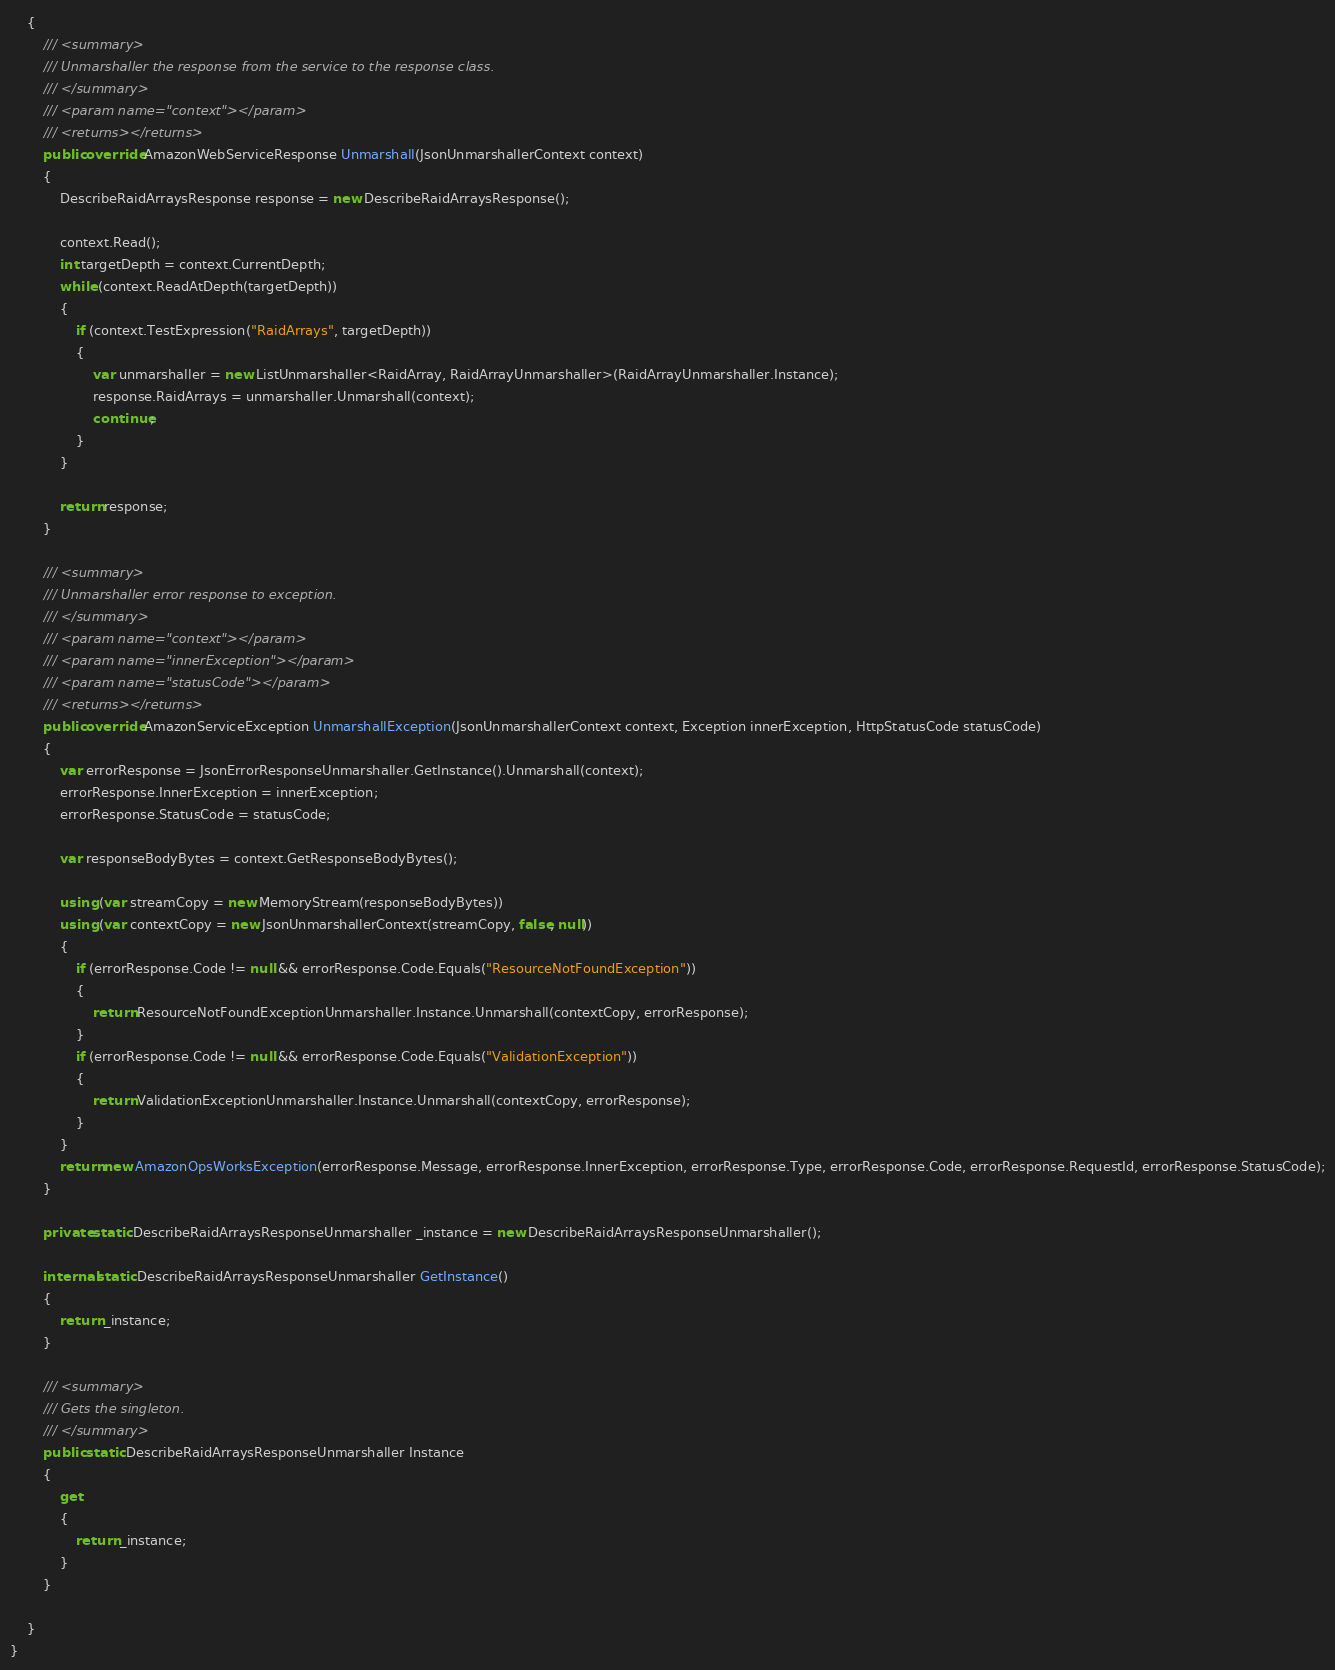Convert code to text. <code><loc_0><loc_0><loc_500><loc_500><_C#_>    {
        /// <summary>
        /// Unmarshaller the response from the service to the response class.
        /// </summary>  
        /// <param name="context"></param>
        /// <returns></returns>
        public override AmazonWebServiceResponse Unmarshall(JsonUnmarshallerContext context)
        {
            DescribeRaidArraysResponse response = new DescribeRaidArraysResponse();

            context.Read();
            int targetDepth = context.CurrentDepth;
            while (context.ReadAtDepth(targetDepth))
            {
                if (context.TestExpression("RaidArrays", targetDepth))
                {
                    var unmarshaller = new ListUnmarshaller<RaidArray, RaidArrayUnmarshaller>(RaidArrayUnmarshaller.Instance);
                    response.RaidArrays = unmarshaller.Unmarshall(context);
                    continue;
                }
            }

            return response;
        }

        /// <summary>
        /// Unmarshaller error response to exception.
        /// </summary>  
        /// <param name="context"></param>
        /// <param name="innerException"></param>
        /// <param name="statusCode"></param>
        /// <returns></returns>
        public override AmazonServiceException UnmarshallException(JsonUnmarshallerContext context, Exception innerException, HttpStatusCode statusCode)
        {
            var errorResponse = JsonErrorResponseUnmarshaller.GetInstance().Unmarshall(context);
            errorResponse.InnerException = innerException;
            errorResponse.StatusCode = statusCode;

            var responseBodyBytes = context.GetResponseBodyBytes();

            using (var streamCopy = new MemoryStream(responseBodyBytes))
            using (var contextCopy = new JsonUnmarshallerContext(streamCopy, false, null))
            {
                if (errorResponse.Code != null && errorResponse.Code.Equals("ResourceNotFoundException"))
                {
                    return ResourceNotFoundExceptionUnmarshaller.Instance.Unmarshall(contextCopy, errorResponse);
                }
                if (errorResponse.Code != null && errorResponse.Code.Equals("ValidationException"))
                {
                    return ValidationExceptionUnmarshaller.Instance.Unmarshall(contextCopy, errorResponse);
                }
            }
            return new AmazonOpsWorksException(errorResponse.Message, errorResponse.InnerException, errorResponse.Type, errorResponse.Code, errorResponse.RequestId, errorResponse.StatusCode);
        }

        private static DescribeRaidArraysResponseUnmarshaller _instance = new DescribeRaidArraysResponseUnmarshaller();        

        internal static DescribeRaidArraysResponseUnmarshaller GetInstance()
        {
            return _instance;
        }

        /// <summary>
        /// Gets the singleton.
        /// </summary>  
        public static DescribeRaidArraysResponseUnmarshaller Instance
        {
            get
            {
                return _instance;
            }
        }

    }
}</code> 